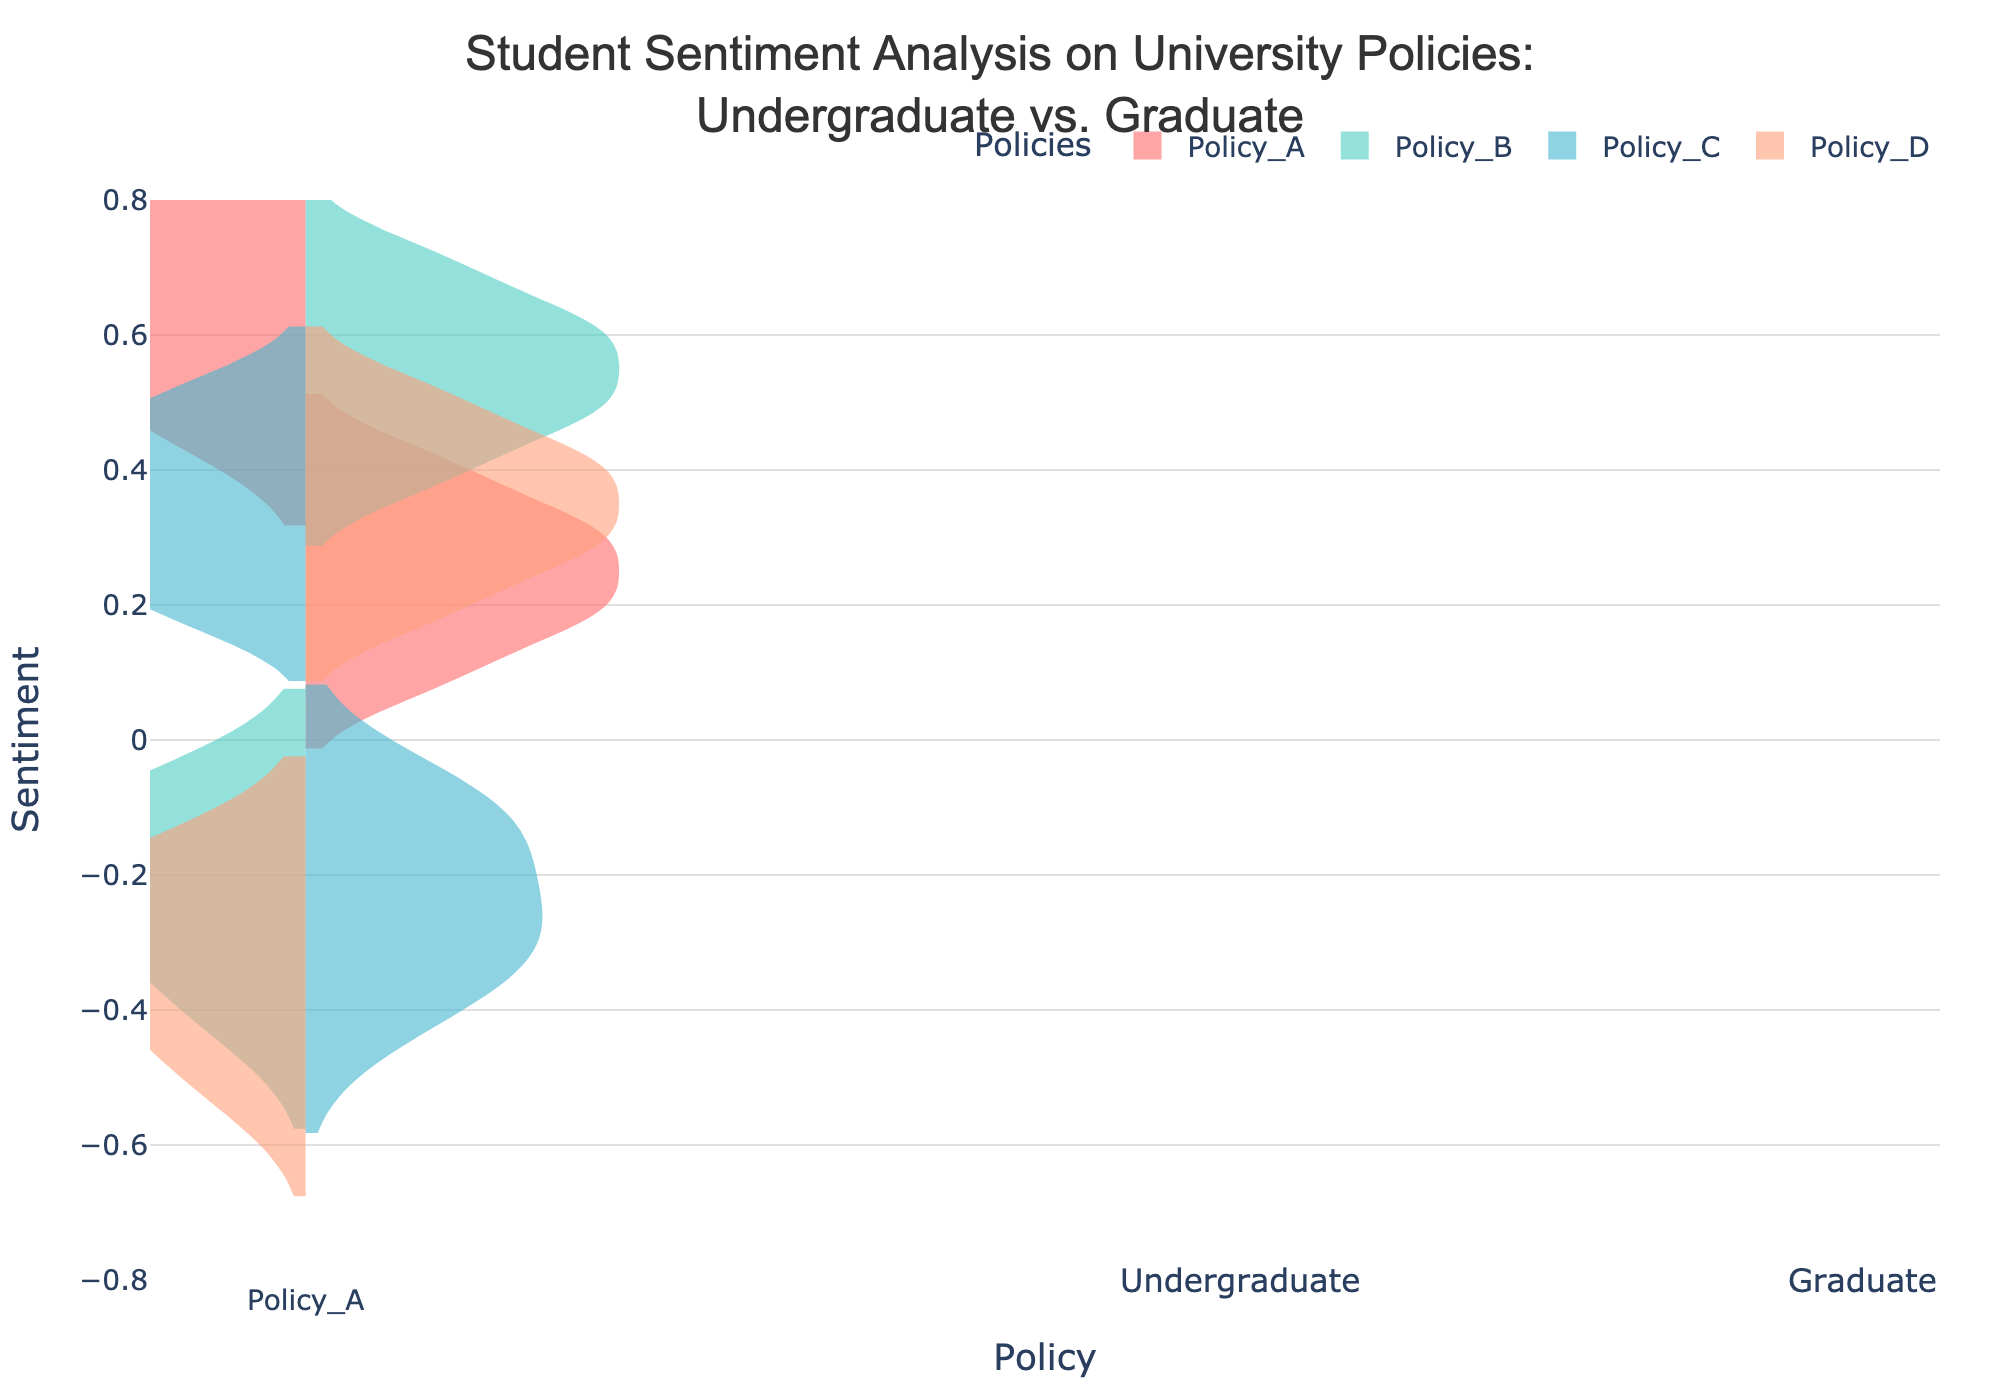What is the title of the figure? The title is centered at the top of the figure. The text reads "Student Sentiment Analysis on University Policies: Undergraduate vs. Graduate".
Answer: "Student Sentiment Analysis on University Policies: Undergraduate vs. Graduate" Which policy shows the highest positive sentiment among graduate students? To find this, look at the right side of the figure where the graduate students' data is plotted. Identify the policy with the highest upward spread on the y-axis.
Answer: Policy_B What is the range of sentiment values for undergraduate students on Policy_C? Locate Policy_C on the x-axis for undergraduate students (left side). Identify the minimum and maximum points on the y-axis.
Answer: -0.5 to 0.5 Which group has a more negative sentiment towards Policy_D, undergraduate or graduate students? Compare the left (undergraduate) and right (graduate) violin plots for Policy_D. Determine which has a broader spread below zero on the y-axis.
Answer: Undergraduate students What is the average sentiment for graduate students on Policy_A? Locate Policy_A on the x-axis for graduate students (right side). Visualize the centroid of the distribution on the y-axis.
Answer: 0.3 Which policy shows the most varied sentiment among undergraduate students? Compare the widths of the violins for undergraduate students (left side) across all policies. The policy with the widest violin indicates the most varied sentiment.
Answer: Policy_D Is there any policy where both undergraduate and graduate students have a generally negative sentiment? Look for policies where both the left and right violins have a significant portion below zero on the y-axis.
Answer: No Which student group has a more positive sentiment towards Policy_A in general? Compare the overall distribution heights of the left (undergraduate) and right (graduate) violins for Policy_A.
Answer: Undergraduate students What is the approximate median sentiment for graduate students towards Policy_B? Locate Policy_B on the x-axis for graduate students (right side). Identify the middle point of the violin plot on the y-axis.
Answer: 0.55 